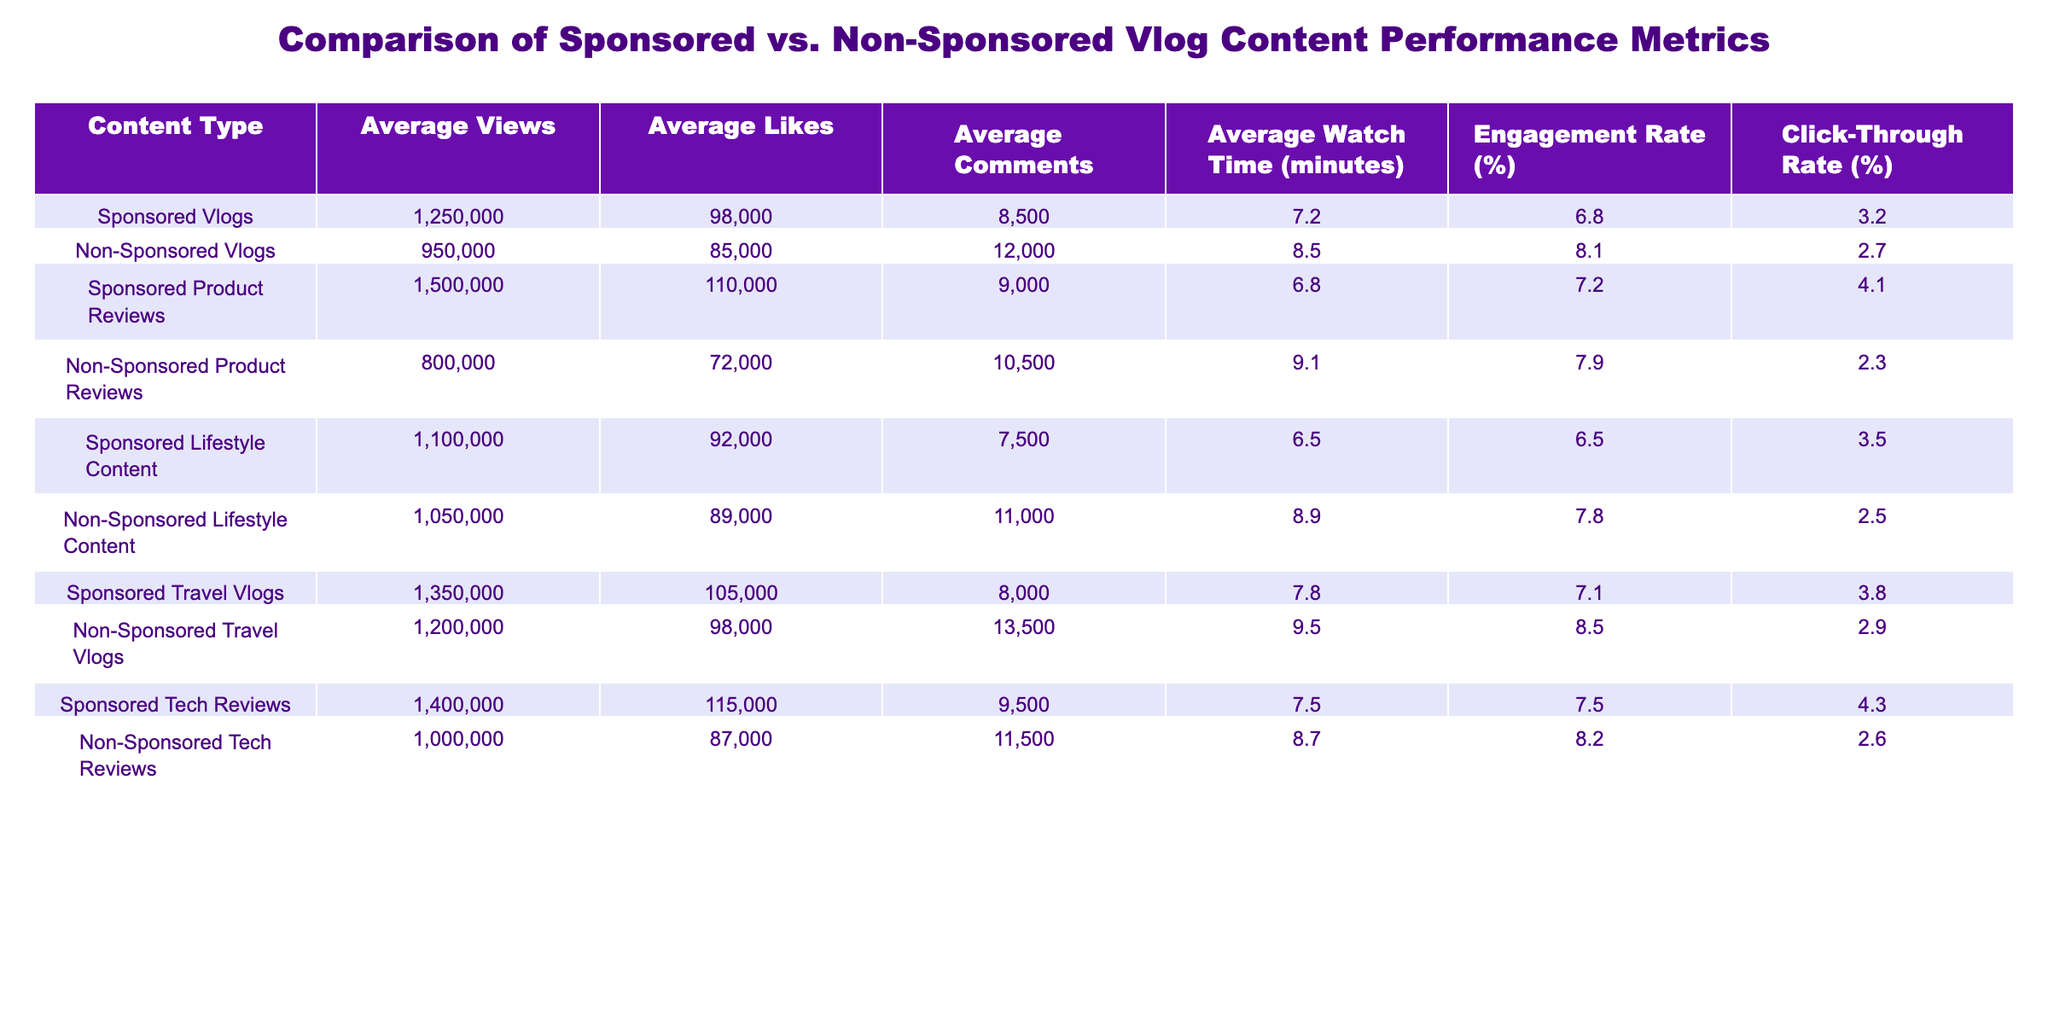What are the average views for sponsored vlogs? The table indicates that the average views for sponsored vlogs is 1,250,000.
Answer: 1,250,000 What is the average engagement rate for non-sponsored lifestyle content? The table shows that the average engagement rate for non-sponsored lifestyle content is 7.8%.
Answer: 7.8% Which type of non-sponsored vlog has the highest average comments? By examining the table, non-sponsored travel vlogs have the highest average comments at 13,500.
Answer: 13,500 How many more average likes do sponsored tech reviews have compared to non-sponsored tech reviews? The average likes for sponsored tech reviews is 115,000, while for non-sponsored tech reviews it is 87,000. The difference is 115,000 - 87,000 = 28,000.
Answer: 28,000 What is the engagement rate difference between sponsored and non-sponsored product reviews? The engagement rate for sponsored product reviews is 7.2% and for non-sponsored product reviews is 7.9%. The difference is 7.9% - 7.2% = 0.7%.
Answer: 0.7% Is the average watch time longer for sponsored travel vlogs compared to non-sponsored travel vlogs? Sponsored travel vlogs have an average watch time of 7.8 minutes, while non-sponsored travel vlogs have 9.5 minutes, indicating that non-sponsored travel vlogs have a longer average watch time.
Answer: No What is the total average watch time for all types of sponsored content? We sum the average watch times for all sponsored content types: 7.2 (vlogs) + 6.8 (product reviews) + 6.5 (lifestyle) + 7.8 (travel) + 7.5 (tech) = 35.8 minutes. There are five types, so the average is 35.8 / 5 = 7.16 minutes.
Answer: 7.16 Which type of content has the highest average click-through rate overall? By analyzing the click-through rates, sponsored product reviews have the highest at 4.1%, followed by sponsored tech reviews at 4.3%. Hence, the highest is for sponsored tech reviews.
Answer: Sponsored Tech Reviews Do non-sponsored vlogs, in general, have a higher average number of comments compared to sponsored vlogs? The average comments for non-sponsored vlogs is 12,000 compared to 8,500 for sponsored vlogs, indicating that non-sponsored vlogs have a higher average number of comments.
Answer: Yes What is the average number of views for sponsored lifestyle content? The average views for sponsored lifestyle content is shown in the table as 1,100,000.
Answer: 1,100,000 How does the average watch time for non-sponsored travel vlogs compare to non-sponsored product reviews? Non-sponsored travel vlogs have an average watch time of 9.5 minutes, while non-sponsored product reviews have an average of 9.1 minutes, thus non-sponsored travel vlogs have a longer average watch time.
Answer: Yes 